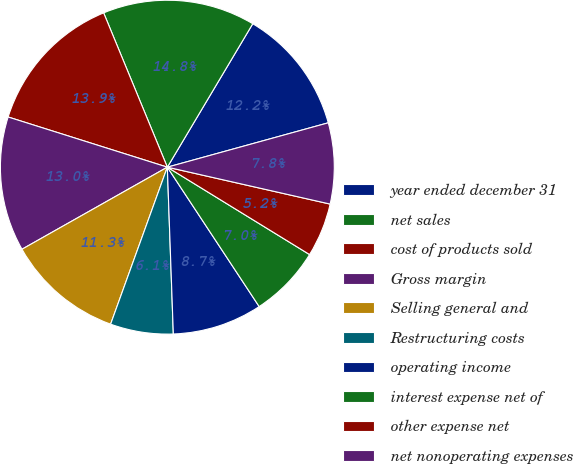Convert chart. <chart><loc_0><loc_0><loc_500><loc_500><pie_chart><fcel>year ended december 31<fcel>net sales<fcel>cost of products sold<fcel>Gross margin<fcel>Selling general and<fcel>Restructuring costs<fcel>operating income<fcel>interest expense net of<fcel>other expense net<fcel>net nonoperating expenses<nl><fcel>12.17%<fcel>14.78%<fcel>13.91%<fcel>13.04%<fcel>11.3%<fcel>6.09%<fcel>8.7%<fcel>6.96%<fcel>5.22%<fcel>7.83%<nl></chart> 